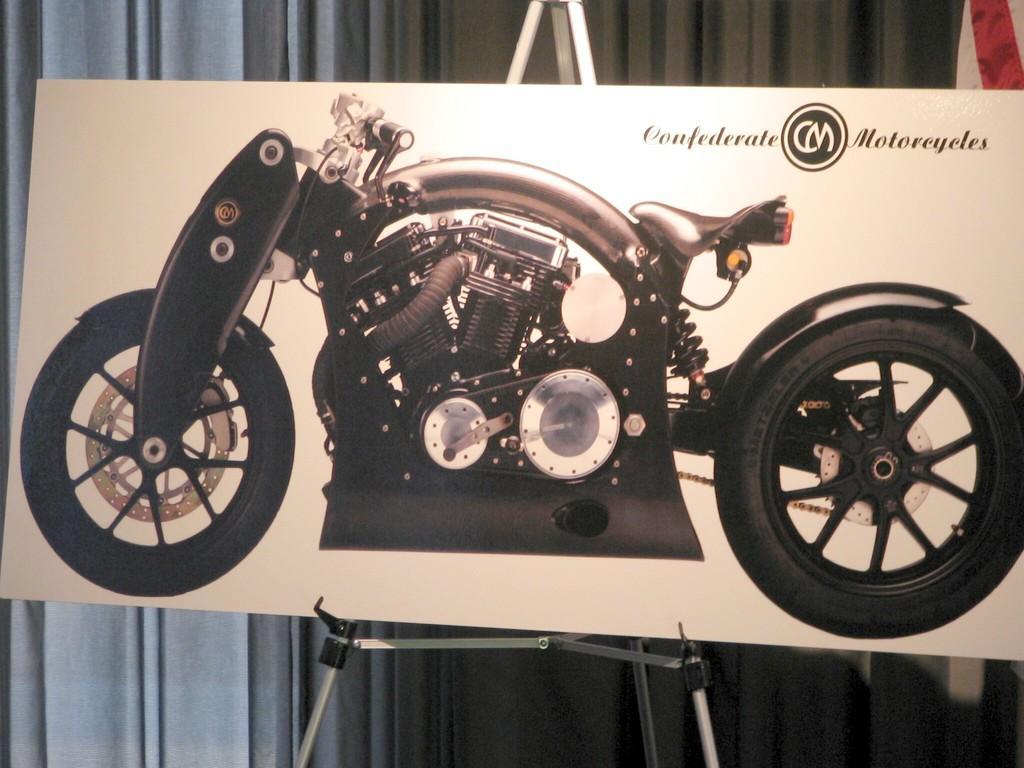How would you summarize this image in a sentence or two? In this picture there is a board placed on a stand which has an image of a bike and some thing written in the right top corner on it and there are curtains in the background. 